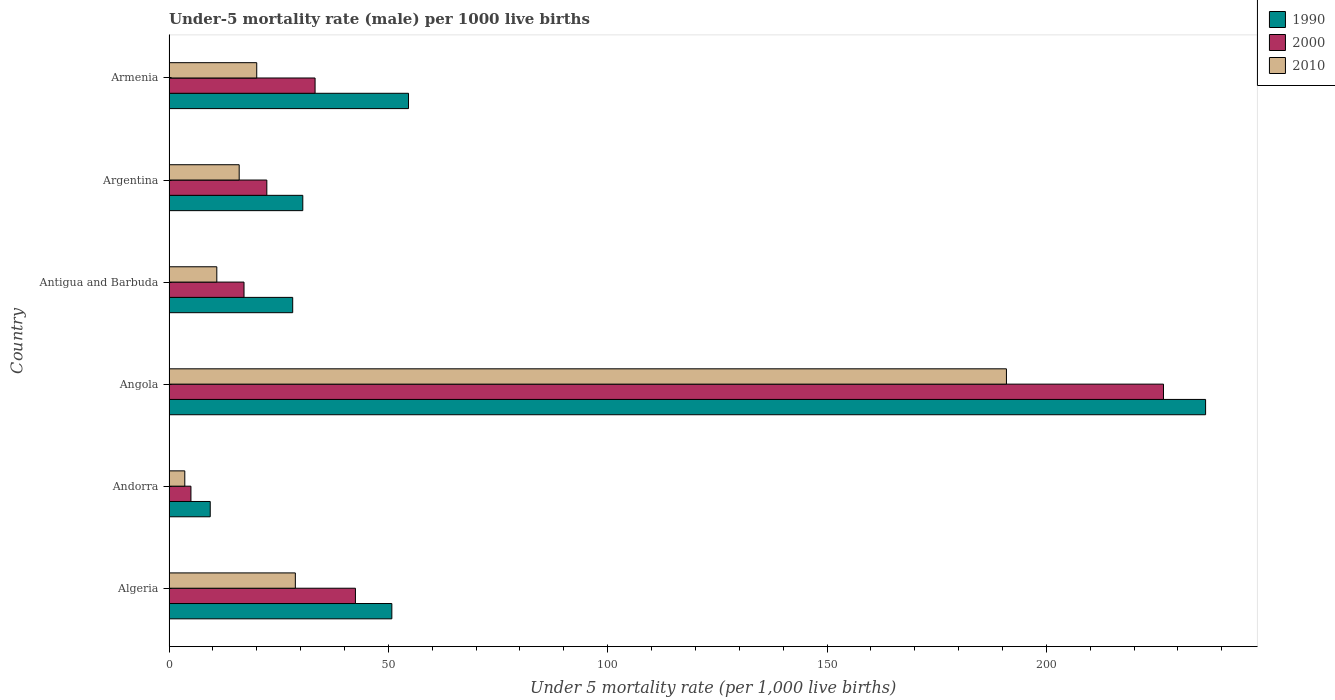Are the number of bars on each tick of the Y-axis equal?
Your response must be concise. Yes. How many bars are there on the 1st tick from the top?
Give a very brief answer. 3. How many bars are there on the 3rd tick from the bottom?
Make the answer very short. 3. What is the label of the 4th group of bars from the top?
Provide a succinct answer. Angola. In how many cases, is the number of bars for a given country not equal to the number of legend labels?
Your response must be concise. 0. What is the under-five mortality rate in 2000 in Armenia?
Keep it short and to the point. 33.3. Across all countries, what is the maximum under-five mortality rate in 2010?
Keep it short and to the point. 190.9. In which country was the under-five mortality rate in 1990 maximum?
Make the answer very short. Angola. In which country was the under-five mortality rate in 2010 minimum?
Your response must be concise. Andorra. What is the total under-five mortality rate in 1990 in the graph?
Provide a short and direct response. 409.8. What is the difference between the under-five mortality rate in 2010 in Andorra and that in Antigua and Barbuda?
Ensure brevity in your answer.  -7.3. What is the difference between the under-five mortality rate in 1990 in Argentina and the under-five mortality rate in 2010 in Armenia?
Give a very brief answer. 10.5. What is the average under-five mortality rate in 2000 per country?
Keep it short and to the point. 57.82. What is the difference between the under-five mortality rate in 2000 and under-five mortality rate in 2010 in Armenia?
Offer a very short reply. 13.3. In how many countries, is the under-five mortality rate in 2000 greater than 190 ?
Offer a very short reply. 1. What is the ratio of the under-five mortality rate in 2000 in Antigua and Barbuda to that in Armenia?
Ensure brevity in your answer.  0.51. Is the under-five mortality rate in 1990 in Andorra less than that in Antigua and Barbuda?
Keep it short and to the point. Yes. What is the difference between the highest and the second highest under-five mortality rate in 1990?
Your response must be concise. 181.7. What is the difference between the highest and the lowest under-five mortality rate in 2000?
Offer a terse response. 221.7. In how many countries, is the under-five mortality rate in 2010 greater than the average under-five mortality rate in 2010 taken over all countries?
Offer a very short reply. 1. Is it the case that in every country, the sum of the under-five mortality rate in 1990 and under-five mortality rate in 2000 is greater than the under-five mortality rate in 2010?
Give a very brief answer. Yes. How many bars are there?
Your answer should be compact. 18. Are all the bars in the graph horizontal?
Give a very brief answer. Yes. Where does the legend appear in the graph?
Make the answer very short. Top right. How are the legend labels stacked?
Ensure brevity in your answer.  Vertical. What is the title of the graph?
Make the answer very short. Under-5 mortality rate (male) per 1000 live births. Does "1995" appear as one of the legend labels in the graph?
Offer a terse response. No. What is the label or title of the X-axis?
Provide a short and direct response. Under 5 mortality rate (per 1,0 live births). What is the label or title of the Y-axis?
Your answer should be very brief. Country. What is the Under 5 mortality rate (per 1,000 live births) of 1990 in Algeria?
Your answer should be very brief. 50.8. What is the Under 5 mortality rate (per 1,000 live births) of 2000 in Algeria?
Provide a short and direct response. 42.5. What is the Under 5 mortality rate (per 1,000 live births) in 2010 in Algeria?
Your answer should be very brief. 28.8. What is the Under 5 mortality rate (per 1,000 live births) of 2000 in Andorra?
Offer a terse response. 5. What is the Under 5 mortality rate (per 1,000 live births) in 1990 in Angola?
Provide a succinct answer. 236.3. What is the Under 5 mortality rate (per 1,000 live births) in 2000 in Angola?
Your answer should be very brief. 226.7. What is the Under 5 mortality rate (per 1,000 live births) in 2010 in Angola?
Your answer should be very brief. 190.9. What is the Under 5 mortality rate (per 1,000 live births) of 1990 in Antigua and Barbuda?
Your answer should be very brief. 28.2. What is the Under 5 mortality rate (per 1,000 live births) of 2000 in Antigua and Barbuda?
Offer a very short reply. 17.1. What is the Under 5 mortality rate (per 1,000 live births) of 1990 in Argentina?
Keep it short and to the point. 30.5. What is the Under 5 mortality rate (per 1,000 live births) in 2000 in Argentina?
Make the answer very short. 22.3. What is the Under 5 mortality rate (per 1,000 live births) in 2010 in Argentina?
Give a very brief answer. 16. What is the Under 5 mortality rate (per 1,000 live births) of 1990 in Armenia?
Keep it short and to the point. 54.6. What is the Under 5 mortality rate (per 1,000 live births) in 2000 in Armenia?
Provide a short and direct response. 33.3. Across all countries, what is the maximum Under 5 mortality rate (per 1,000 live births) of 1990?
Ensure brevity in your answer.  236.3. Across all countries, what is the maximum Under 5 mortality rate (per 1,000 live births) in 2000?
Offer a very short reply. 226.7. Across all countries, what is the maximum Under 5 mortality rate (per 1,000 live births) of 2010?
Make the answer very short. 190.9. Across all countries, what is the minimum Under 5 mortality rate (per 1,000 live births) of 1990?
Provide a short and direct response. 9.4. Across all countries, what is the minimum Under 5 mortality rate (per 1,000 live births) of 2000?
Offer a very short reply. 5. Across all countries, what is the minimum Under 5 mortality rate (per 1,000 live births) in 2010?
Your response must be concise. 3.6. What is the total Under 5 mortality rate (per 1,000 live births) in 1990 in the graph?
Give a very brief answer. 409.8. What is the total Under 5 mortality rate (per 1,000 live births) in 2000 in the graph?
Provide a succinct answer. 346.9. What is the total Under 5 mortality rate (per 1,000 live births) in 2010 in the graph?
Ensure brevity in your answer.  270.2. What is the difference between the Under 5 mortality rate (per 1,000 live births) of 1990 in Algeria and that in Andorra?
Your response must be concise. 41.4. What is the difference between the Under 5 mortality rate (per 1,000 live births) in 2000 in Algeria and that in Andorra?
Your answer should be very brief. 37.5. What is the difference between the Under 5 mortality rate (per 1,000 live births) of 2010 in Algeria and that in Andorra?
Give a very brief answer. 25.2. What is the difference between the Under 5 mortality rate (per 1,000 live births) of 1990 in Algeria and that in Angola?
Give a very brief answer. -185.5. What is the difference between the Under 5 mortality rate (per 1,000 live births) of 2000 in Algeria and that in Angola?
Your answer should be compact. -184.2. What is the difference between the Under 5 mortality rate (per 1,000 live births) in 2010 in Algeria and that in Angola?
Give a very brief answer. -162.1. What is the difference between the Under 5 mortality rate (per 1,000 live births) of 1990 in Algeria and that in Antigua and Barbuda?
Ensure brevity in your answer.  22.6. What is the difference between the Under 5 mortality rate (per 1,000 live births) of 2000 in Algeria and that in Antigua and Barbuda?
Your response must be concise. 25.4. What is the difference between the Under 5 mortality rate (per 1,000 live births) in 1990 in Algeria and that in Argentina?
Keep it short and to the point. 20.3. What is the difference between the Under 5 mortality rate (per 1,000 live births) in 2000 in Algeria and that in Argentina?
Provide a short and direct response. 20.2. What is the difference between the Under 5 mortality rate (per 1,000 live births) in 2010 in Algeria and that in Argentina?
Give a very brief answer. 12.8. What is the difference between the Under 5 mortality rate (per 1,000 live births) in 2000 in Algeria and that in Armenia?
Keep it short and to the point. 9.2. What is the difference between the Under 5 mortality rate (per 1,000 live births) in 1990 in Andorra and that in Angola?
Offer a very short reply. -226.9. What is the difference between the Under 5 mortality rate (per 1,000 live births) of 2000 in Andorra and that in Angola?
Offer a very short reply. -221.7. What is the difference between the Under 5 mortality rate (per 1,000 live births) in 2010 in Andorra and that in Angola?
Keep it short and to the point. -187.3. What is the difference between the Under 5 mortality rate (per 1,000 live births) of 1990 in Andorra and that in Antigua and Barbuda?
Make the answer very short. -18.8. What is the difference between the Under 5 mortality rate (per 1,000 live births) of 2000 in Andorra and that in Antigua and Barbuda?
Ensure brevity in your answer.  -12.1. What is the difference between the Under 5 mortality rate (per 1,000 live births) in 1990 in Andorra and that in Argentina?
Provide a succinct answer. -21.1. What is the difference between the Under 5 mortality rate (per 1,000 live births) in 2000 in Andorra and that in Argentina?
Provide a succinct answer. -17.3. What is the difference between the Under 5 mortality rate (per 1,000 live births) in 1990 in Andorra and that in Armenia?
Provide a succinct answer. -45.2. What is the difference between the Under 5 mortality rate (per 1,000 live births) of 2000 in Andorra and that in Armenia?
Provide a short and direct response. -28.3. What is the difference between the Under 5 mortality rate (per 1,000 live births) of 2010 in Andorra and that in Armenia?
Provide a short and direct response. -16.4. What is the difference between the Under 5 mortality rate (per 1,000 live births) in 1990 in Angola and that in Antigua and Barbuda?
Make the answer very short. 208.1. What is the difference between the Under 5 mortality rate (per 1,000 live births) of 2000 in Angola and that in Antigua and Barbuda?
Ensure brevity in your answer.  209.6. What is the difference between the Under 5 mortality rate (per 1,000 live births) in 2010 in Angola and that in Antigua and Barbuda?
Make the answer very short. 180. What is the difference between the Under 5 mortality rate (per 1,000 live births) of 1990 in Angola and that in Argentina?
Offer a terse response. 205.8. What is the difference between the Under 5 mortality rate (per 1,000 live births) in 2000 in Angola and that in Argentina?
Provide a short and direct response. 204.4. What is the difference between the Under 5 mortality rate (per 1,000 live births) in 2010 in Angola and that in Argentina?
Offer a very short reply. 174.9. What is the difference between the Under 5 mortality rate (per 1,000 live births) of 1990 in Angola and that in Armenia?
Your answer should be very brief. 181.7. What is the difference between the Under 5 mortality rate (per 1,000 live births) of 2000 in Angola and that in Armenia?
Provide a short and direct response. 193.4. What is the difference between the Under 5 mortality rate (per 1,000 live births) in 2010 in Angola and that in Armenia?
Keep it short and to the point. 170.9. What is the difference between the Under 5 mortality rate (per 1,000 live births) of 1990 in Antigua and Barbuda and that in Argentina?
Provide a short and direct response. -2.3. What is the difference between the Under 5 mortality rate (per 1,000 live births) of 2010 in Antigua and Barbuda and that in Argentina?
Ensure brevity in your answer.  -5.1. What is the difference between the Under 5 mortality rate (per 1,000 live births) of 1990 in Antigua and Barbuda and that in Armenia?
Offer a very short reply. -26.4. What is the difference between the Under 5 mortality rate (per 1,000 live births) of 2000 in Antigua and Barbuda and that in Armenia?
Offer a very short reply. -16.2. What is the difference between the Under 5 mortality rate (per 1,000 live births) in 2010 in Antigua and Barbuda and that in Armenia?
Your answer should be compact. -9.1. What is the difference between the Under 5 mortality rate (per 1,000 live births) in 1990 in Argentina and that in Armenia?
Your answer should be compact. -24.1. What is the difference between the Under 5 mortality rate (per 1,000 live births) of 1990 in Algeria and the Under 5 mortality rate (per 1,000 live births) of 2000 in Andorra?
Give a very brief answer. 45.8. What is the difference between the Under 5 mortality rate (per 1,000 live births) of 1990 in Algeria and the Under 5 mortality rate (per 1,000 live births) of 2010 in Andorra?
Keep it short and to the point. 47.2. What is the difference between the Under 5 mortality rate (per 1,000 live births) in 2000 in Algeria and the Under 5 mortality rate (per 1,000 live births) in 2010 in Andorra?
Make the answer very short. 38.9. What is the difference between the Under 5 mortality rate (per 1,000 live births) of 1990 in Algeria and the Under 5 mortality rate (per 1,000 live births) of 2000 in Angola?
Provide a succinct answer. -175.9. What is the difference between the Under 5 mortality rate (per 1,000 live births) of 1990 in Algeria and the Under 5 mortality rate (per 1,000 live births) of 2010 in Angola?
Your response must be concise. -140.1. What is the difference between the Under 5 mortality rate (per 1,000 live births) of 2000 in Algeria and the Under 5 mortality rate (per 1,000 live births) of 2010 in Angola?
Offer a very short reply. -148.4. What is the difference between the Under 5 mortality rate (per 1,000 live births) in 1990 in Algeria and the Under 5 mortality rate (per 1,000 live births) in 2000 in Antigua and Barbuda?
Make the answer very short. 33.7. What is the difference between the Under 5 mortality rate (per 1,000 live births) of 1990 in Algeria and the Under 5 mortality rate (per 1,000 live births) of 2010 in Antigua and Barbuda?
Make the answer very short. 39.9. What is the difference between the Under 5 mortality rate (per 1,000 live births) of 2000 in Algeria and the Under 5 mortality rate (per 1,000 live births) of 2010 in Antigua and Barbuda?
Your answer should be very brief. 31.6. What is the difference between the Under 5 mortality rate (per 1,000 live births) in 1990 in Algeria and the Under 5 mortality rate (per 1,000 live births) in 2000 in Argentina?
Offer a terse response. 28.5. What is the difference between the Under 5 mortality rate (per 1,000 live births) of 1990 in Algeria and the Under 5 mortality rate (per 1,000 live births) of 2010 in Argentina?
Keep it short and to the point. 34.8. What is the difference between the Under 5 mortality rate (per 1,000 live births) of 1990 in Algeria and the Under 5 mortality rate (per 1,000 live births) of 2000 in Armenia?
Give a very brief answer. 17.5. What is the difference between the Under 5 mortality rate (per 1,000 live births) in 1990 in Algeria and the Under 5 mortality rate (per 1,000 live births) in 2010 in Armenia?
Make the answer very short. 30.8. What is the difference between the Under 5 mortality rate (per 1,000 live births) in 1990 in Andorra and the Under 5 mortality rate (per 1,000 live births) in 2000 in Angola?
Your answer should be compact. -217.3. What is the difference between the Under 5 mortality rate (per 1,000 live births) of 1990 in Andorra and the Under 5 mortality rate (per 1,000 live births) of 2010 in Angola?
Ensure brevity in your answer.  -181.5. What is the difference between the Under 5 mortality rate (per 1,000 live births) in 2000 in Andorra and the Under 5 mortality rate (per 1,000 live births) in 2010 in Angola?
Give a very brief answer. -185.9. What is the difference between the Under 5 mortality rate (per 1,000 live births) of 1990 in Andorra and the Under 5 mortality rate (per 1,000 live births) of 2000 in Antigua and Barbuda?
Offer a very short reply. -7.7. What is the difference between the Under 5 mortality rate (per 1,000 live births) of 1990 in Andorra and the Under 5 mortality rate (per 1,000 live births) of 2000 in Argentina?
Your answer should be very brief. -12.9. What is the difference between the Under 5 mortality rate (per 1,000 live births) in 1990 in Andorra and the Under 5 mortality rate (per 1,000 live births) in 2000 in Armenia?
Offer a terse response. -23.9. What is the difference between the Under 5 mortality rate (per 1,000 live births) in 1990 in Angola and the Under 5 mortality rate (per 1,000 live births) in 2000 in Antigua and Barbuda?
Offer a very short reply. 219.2. What is the difference between the Under 5 mortality rate (per 1,000 live births) of 1990 in Angola and the Under 5 mortality rate (per 1,000 live births) of 2010 in Antigua and Barbuda?
Provide a succinct answer. 225.4. What is the difference between the Under 5 mortality rate (per 1,000 live births) of 2000 in Angola and the Under 5 mortality rate (per 1,000 live births) of 2010 in Antigua and Barbuda?
Your answer should be very brief. 215.8. What is the difference between the Under 5 mortality rate (per 1,000 live births) of 1990 in Angola and the Under 5 mortality rate (per 1,000 live births) of 2000 in Argentina?
Your answer should be very brief. 214. What is the difference between the Under 5 mortality rate (per 1,000 live births) in 1990 in Angola and the Under 5 mortality rate (per 1,000 live births) in 2010 in Argentina?
Offer a very short reply. 220.3. What is the difference between the Under 5 mortality rate (per 1,000 live births) of 2000 in Angola and the Under 5 mortality rate (per 1,000 live births) of 2010 in Argentina?
Give a very brief answer. 210.7. What is the difference between the Under 5 mortality rate (per 1,000 live births) in 1990 in Angola and the Under 5 mortality rate (per 1,000 live births) in 2000 in Armenia?
Ensure brevity in your answer.  203. What is the difference between the Under 5 mortality rate (per 1,000 live births) of 1990 in Angola and the Under 5 mortality rate (per 1,000 live births) of 2010 in Armenia?
Your answer should be compact. 216.3. What is the difference between the Under 5 mortality rate (per 1,000 live births) in 2000 in Angola and the Under 5 mortality rate (per 1,000 live births) in 2010 in Armenia?
Offer a very short reply. 206.7. What is the difference between the Under 5 mortality rate (per 1,000 live births) of 1990 in Antigua and Barbuda and the Under 5 mortality rate (per 1,000 live births) of 2010 in Argentina?
Your answer should be compact. 12.2. What is the difference between the Under 5 mortality rate (per 1,000 live births) of 2000 in Argentina and the Under 5 mortality rate (per 1,000 live births) of 2010 in Armenia?
Offer a terse response. 2.3. What is the average Under 5 mortality rate (per 1,000 live births) of 1990 per country?
Provide a short and direct response. 68.3. What is the average Under 5 mortality rate (per 1,000 live births) of 2000 per country?
Keep it short and to the point. 57.82. What is the average Under 5 mortality rate (per 1,000 live births) in 2010 per country?
Provide a succinct answer. 45.03. What is the difference between the Under 5 mortality rate (per 1,000 live births) in 1990 and Under 5 mortality rate (per 1,000 live births) in 2000 in Algeria?
Make the answer very short. 8.3. What is the difference between the Under 5 mortality rate (per 1,000 live births) in 1990 and Under 5 mortality rate (per 1,000 live births) in 2000 in Andorra?
Offer a very short reply. 4.4. What is the difference between the Under 5 mortality rate (per 1,000 live births) of 1990 and Under 5 mortality rate (per 1,000 live births) of 2010 in Andorra?
Ensure brevity in your answer.  5.8. What is the difference between the Under 5 mortality rate (per 1,000 live births) in 2000 and Under 5 mortality rate (per 1,000 live births) in 2010 in Andorra?
Your answer should be very brief. 1.4. What is the difference between the Under 5 mortality rate (per 1,000 live births) in 1990 and Under 5 mortality rate (per 1,000 live births) in 2000 in Angola?
Offer a terse response. 9.6. What is the difference between the Under 5 mortality rate (per 1,000 live births) in 1990 and Under 5 mortality rate (per 1,000 live births) in 2010 in Angola?
Ensure brevity in your answer.  45.4. What is the difference between the Under 5 mortality rate (per 1,000 live births) in 2000 and Under 5 mortality rate (per 1,000 live births) in 2010 in Angola?
Provide a succinct answer. 35.8. What is the difference between the Under 5 mortality rate (per 1,000 live births) in 2000 and Under 5 mortality rate (per 1,000 live births) in 2010 in Antigua and Barbuda?
Provide a succinct answer. 6.2. What is the difference between the Under 5 mortality rate (per 1,000 live births) in 1990 and Under 5 mortality rate (per 1,000 live births) in 2000 in Argentina?
Give a very brief answer. 8.2. What is the difference between the Under 5 mortality rate (per 1,000 live births) in 1990 and Under 5 mortality rate (per 1,000 live births) in 2010 in Argentina?
Offer a terse response. 14.5. What is the difference between the Under 5 mortality rate (per 1,000 live births) of 1990 and Under 5 mortality rate (per 1,000 live births) of 2000 in Armenia?
Offer a very short reply. 21.3. What is the difference between the Under 5 mortality rate (per 1,000 live births) in 1990 and Under 5 mortality rate (per 1,000 live births) in 2010 in Armenia?
Your answer should be very brief. 34.6. What is the ratio of the Under 5 mortality rate (per 1,000 live births) in 1990 in Algeria to that in Andorra?
Your response must be concise. 5.4. What is the ratio of the Under 5 mortality rate (per 1,000 live births) of 2000 in Algeria to that in Andorra?
Provide a short and direct response. 8.5. What is the ratio of the Under 5 mortality rate (per 1,000 live births) in 1990 in Algeria to that in Angola?
Provide a succinct answer. 0.21. What is the ratio of the Under 5 mortality rate (per 1,000 live births) in 2000 in Algeria to that in Angola?
Ensure brevity in your answer.  0.19. What is the ratio of the Under 5 mortality rate (per 1,000 live births) in 2010 in Algeria to that in Angola?
Provide a succinct answer. 0.15. What is the ratio of the Under 5 mortality rate (per 1,000 live births) in 1990 in Algeria to that in Antigua and Barbuda?
Offer a very short reply. 1.8. What is the ratio of the Under 5 mortality rate (per 1,000 live births) in 2000 in Algeria to that in Antigua and Barbuda?
Provide a short and direct response. 2.49. What is the ratio of the Under 5 mortality rate (per 1,000 live births) of 2010 in Algeria to that in Antigua and Barbuda?
Provide a succinct answer. 2.64. What is the ratio of the Under 5 mortality rate (per 1,000 live births) in 1990 in Algeria to that in Argentina?
Keep it short and to the point. 1.67. What is the ratio of the Under 5 mortality rate (per 1,000 live births) in 2000 in Algeria to that in Argentina?
Your answer should be compact. 1.91. What is the ratio of the Under 5 mortality rate (per 1,000 live births) of 1990 in Algeria to that in Armenia?
Keep it short and to the point. 0.93. What is the ratio of the Under 5 mortality rate (per 1,000 live births) of 2000 in Algeria to that in Armenia?
Offer a terse response. 1.28. What is the ratio of the Under 5 mortality rate (per 1,000 live births) in 2010 in Algeria to that in Armenia?
Your response must be concise. 1.44. What is the ratio of the Under 5 mortality rate (per 1,000 live births) in 1990 in Andorra to that in Angola?
Make the answer very short. 0.04. What is the ratio of the Under 5 mortality rate (per 1,000 live births) of 2000 in Andorra to that in Angola?
Your response must be concise. 0.02. What is the ratio of the Under 5 mortality rate (per 1,000 live births) in 2010 in Andorra to that in Angola?
Provide a succinct answer. 0.02. What is the ratio of the Under 5 mortality rate (per 1,000 live births) in 2000 in Andorra to that in Antigua and Barbuda?
Provide a succinct answer. 0.29. What is the ratio of the Under 5 mortality rate (per 1,000 live births) in 2010 in Andorra to that in Antigua and Barbuda?
Your response must be concise. 0.33. What is the ratio of the Under 5 mortality rate (per 1,000 live births) in 1990 in Andorra to that in Argentina?
Offer a very short reply. 0.31. What is the ratio of the Under 5 mortality rate (per 1,000 live births) of 2000 in Andorra to that in Argentina?
Keep it short and to the point. 0.22. What is the ratio of the Under 5 mortality rate (per 1,000 live births) in 2010 in Andorra to that in Argentina?
Your response must be concise. 0.23. What is the ratio of the Under 5 mortality rate (per 1,000 live births) of 1990 in Andorra to that in Armenia?
Your response must be concise. 0.17. What is the ratio of the Under 5 mortality rate (per 1,000 live births) in 2000 in Andorra to that in Armenia?
Provide a short and direct response. 0.15. What is the ratio of the Under 5 mortality rate (per 1,000 live births) of 2010 in Andorra to that in Armenia?
Provide a short and direct response. 0.18. What is the ratio of the Under 5 mortality rate (per 1,000 live births) of 1990 in Angola to that in Antigua and Barbuda?
Make the answer very short. 8.38. What is the ratio of the Under 5 mortality rate (per 1,000 live births) in 2000 in Angola to that in Antigua and Barbuda?
Ensure brevity in your answer.  13.26. What is the ratio of the Under 5 mortality rate (per 1,000 live births) in 2010 in Angola to that in Antigua and Barbuda?
Provide a succinct answer. 17.51. What is the ratio of the Under 5 mortality rate (per 1,000 live births) of 1990 in Angola to that in Argentina?
Provide a succinct answer. 7.75. What is the ratio of the Under 5 mortality rate (per 1,000 live births) of 2000 in Angola to that in Argentina?
Make the answer very short. 10.17. What is the ratio of the Under 5 mortality rate (per 1,000 live births) in 2010 in Angola to that in Argentina?
Your answer should be compact. 11.93. What is the ratio of the Under 5 mortality rate (per 1,000 live births) of 1990 in Angola to that in Armenia?
Your response must be concise. 4.33. What is the ratio of the Under 5 mortality rate (per 1,000 live births) in 2000 in Angola to that in Armenia?
Your answer should be compact. 6.81. What is the ratio of the Under 5 mortality rate (per 1,000 live births) in 2010 in Angola to that in Armenia?
Give a very brief answer. 9.54. What is the ratio of the Under 5 mortality rate (per 1,000 live births) in 1990 in Antigua and Barbuda to that in Argentina?
Your answer should be compact. 0.92. What is the ratio of the Under 5 mortality rate (per 1,000 live births) of 2000 in Antigua and Barbuda to that in Argentina?
Provide a short and direct response. 0.77. What is the ratio of the Under 5 mortality rate (per 1,000 live births) in 2010 in Antigua and Barbuda to that in Argentina?
Give a very brief answer. 0.68. What is the ratio of the Under 5 mortality rate (per 1,000 live births) of 1990 in Antigua and Barbuda to that in Armenia?
Your answer should be very brief. 0.52. What is the ratio of the Under 5 mortality rate (per 1,000 live births) in 2000 in Antigua and Barbuda to that in Armenia?
Your answer should be compact. 0.51. What is the ratio of the Under 5 mortality rate (per 1,000 live births) in 2010 in Antigua and Barbuda to that in Armenia?
Make the answer very short. 0.55. What is the ratio of the Under 5 mortality rate (per 1,000 live births) in 1990 in Argentina to that in Armenia?
Ensure brevity in your answer.  0.56. What is the ratio of the Under 5 mortality rate (per 1,000 live births) of 2000 in Argentina to that in Armenia?
Make the answer very short. 0.67. What is the ratio of the Under 5 mortality rate (per 1,000 live births) of 2010 in Argentina to that in Armenia?
Make the answer very short. 0.8. What is the difference between the highest and the second highest Under 5 mortality rate (per 1,000 live births) of 1990?
Your answer should be very brief. 181.7. What is the difference between the highest and the second highest Under 5 mortality rate (per 1,000 live births) of 2000?
Ensure brevity in your answer.  184.2. What is the difference between the highest and the second highest Under 5 mortality rate (per 1,000 live births) of 2010?
Offer a terse response. 162.1. What is the difference between the highest and the lowest Under 5 mortality rate (per 1,000 live births) in 1990?
Provide a succinct answer. 226.9. What is the difference between the highest and the lowest Under 5 mortality rate (per 1,000 live births) in 2000?
Ensure brevity in your answer.  221.7. What is the difference between the highest and the lowest Under 5 mortality rate (per 1,000 live births) of 2010?
Offer a very short reply. 187.3. 